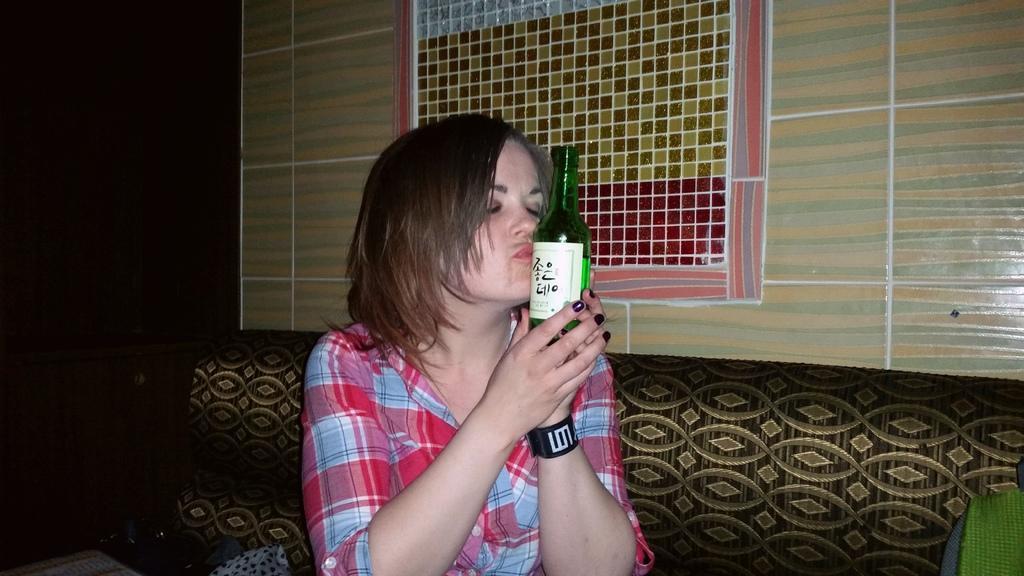Could you give a brief overview of what you see in this image? In this picture we can see a woman, she is holding a bottle and in the background we can see a sofa, wall, window. 